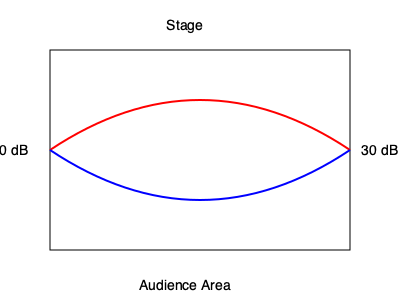Given the 2D representation of an arena's acoustic properties for a concert, where the red curve represents the sound distribution for high frequencies and the blue curve represents low frequencies, calculate the difference in decibel (dB) levels between the stage area and the back of the audience area. Assume a linear decrease in sound intensity from the stage (50 dB) to the back of the arena (30 dB), and the arena is 100 meters long. What is the rate of sound intensity decrease per meter? To solve this problem, we need to follow these steps:

1. Identify the given information:
   - Sound level at the stage: 50 dB
   - Sound level at the back of the arena: 30 dB
   - Arena length: 100 meters

2. Calculate the total decrease in sound intensity:
   $\text{Total decrease} = 50 \text{ dB} - 30 \text{ dB} = 20 \text{ dB}$

3. Calculate the rate of decrease per meter:
   $\text{Rate of decrease} = \frac{\text{Total decrease}}{\text{Arena length}}$
   
   $\text{Rate of decrease} = \frac{20 \text{ dB}}{100 \text{ m}} = 0.2 \text{ dB/m}$

This means that for every meter from the stage to the back of the arena, the sound intensity decreases by 0.2 dB.

4. Verify the calculation:
   $0.2 \text{ dB/m} \times 100 \text{ m} = 20 \text{ dB}$, which matches the total decrease.

The rate of sound intensity decrease is linear in this simplified model, which helps in planning speaker placements and sound reinforcement systems to ensure consistent audio quality throughout the arena.
Answer: 0.2 dB/m 